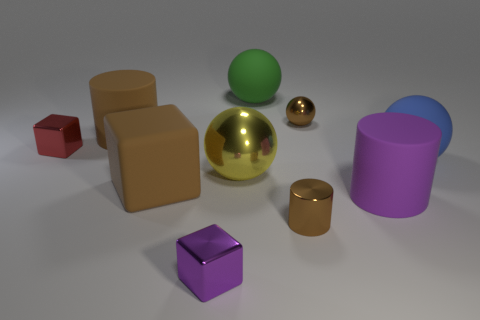Subtract 1 cylinders. How many cylinders are left? 2 Subtract all brown balls. How many balls are left? 3 Subtract all small cubes. How many cubes are left? 1 Subtract all red balls. Subtract all blue cylinders. How many balls are left? 4 Subtract all cubes. How many objects are left? 7 Subtract all small green shiny cylinders. Subtract all large matte things. How many objects are left? 5 Add 9 large blue matte balls. How many large blue matte balls are left? 10 Add 6 large brown things. How many large brown things exist? 8 Subtract 1 purple blocks. How many objects are left? 9 